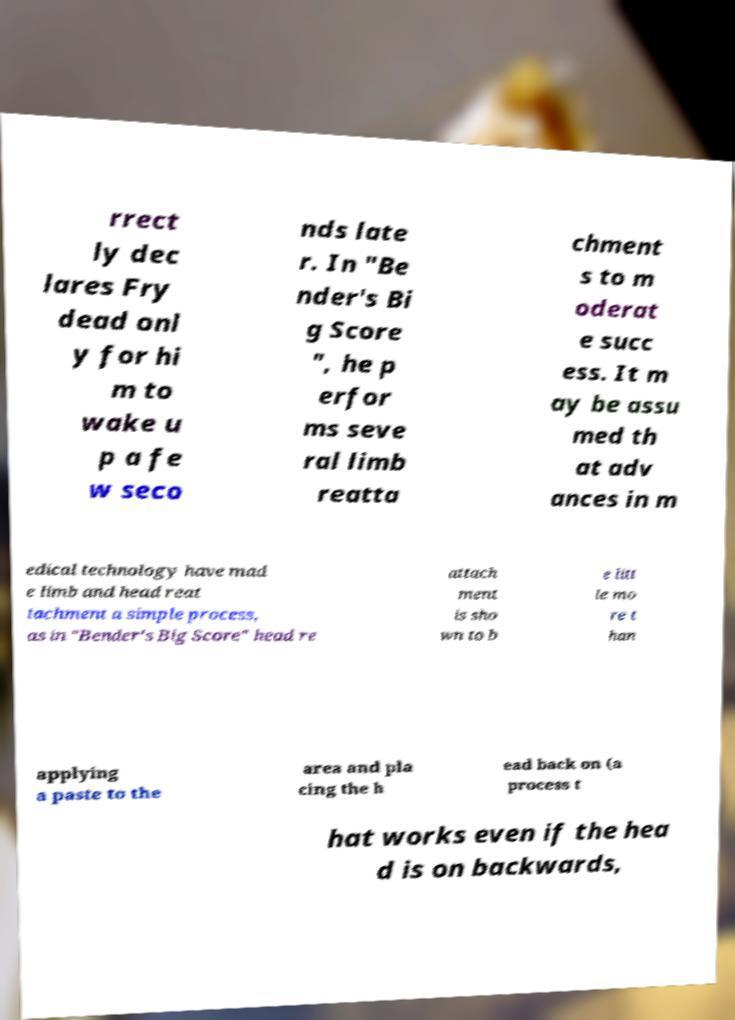What messages or text are displayed in this image? I need them in a readable, typed format. rrect ly dec lares Fry dead onl y for hi m to wake u p a fe w seco nds late r. In "Be nder's Bi g Score ", he p erfor ms seve ral limb reatta chment s to m oderat e succ ess. It m ay be assu med th at adv ances in m edical technology have mad e limb and head reat tachment a simple process, as in "Bender's Big Score" head re attach ment is sho wn to b e litt le mo re t han applying a paste to the area and pla cing the h ead back on (a process t hat works even if the hea d is on backwards, 